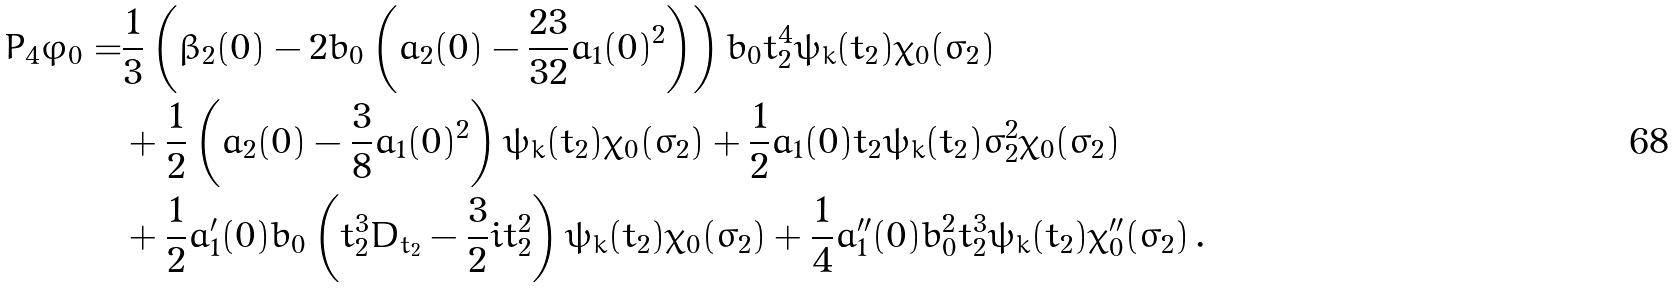<formula> <loc_0><loc_0><loc_500><loc_500>P _ { 4 } \varphi _ { 0 } = & \frac { 1 } { 3 } \left ( \beta _ { 2 } ( 0 ) - 2 b _ { 0 } \left ( a _ { 2 } ( 0 ) - \frac { 2 3 } { 3 2 } a _ { 1 } ( 0 ) ^ { 2 } \right ) \right ) b _ { 0 } t ^ { 4 } _ { 2 } \psi _ { k } ( t _ { 2 } ) \chi _ { 0 } ( \sigma _ { 2 } ) \\ & + \frac { 1 } { 2 } \left ( a _ { 2 } ( 0 ) - \frac { 3 } { 8 } a _ { 1 } ( 0 ) ^ { 2 } \right ) \psi _ { k } ( t _ { 2 } ) \chi _ { 0 } ( \sigma _ { 2 } ) + \frac { 1 } { 2 } a _ { 1 } ( 0 ) t _ { 2 } \psi _ { k } ( t _ { 2 } ) \sigma _ { 2 } ^ { 2 } \chi _ { 0 } ( \sigma _ { 2 } ) \\ & + \frac { 1 } { 2 } a ^ { \prime } _ { 1 } ( 0 ) b _ { 0 } \left ( t ^ { 3 } _ { 2 } D _ { t _ { 2 } } - \frac { 3 } { 2 } i t ^ { 2 } _ { 2 } \right ) \psi _ { k } ( t _ { 2 } ) \chi _ { 0 } ( \sigma _ { 2 } ) + \frac { 1 } { 4 } a ^ { \prime \prime } _ { 1 } ( 0 ) b ^ { 2 } _ { 0 } t _ { 2 } ^ { 3 } \psi _ { k } ( t _ { 2 } ) \chi ^ { \prime \prime } _ { 0 } ( \sigma _ { 2 } ) \, .</formula> 